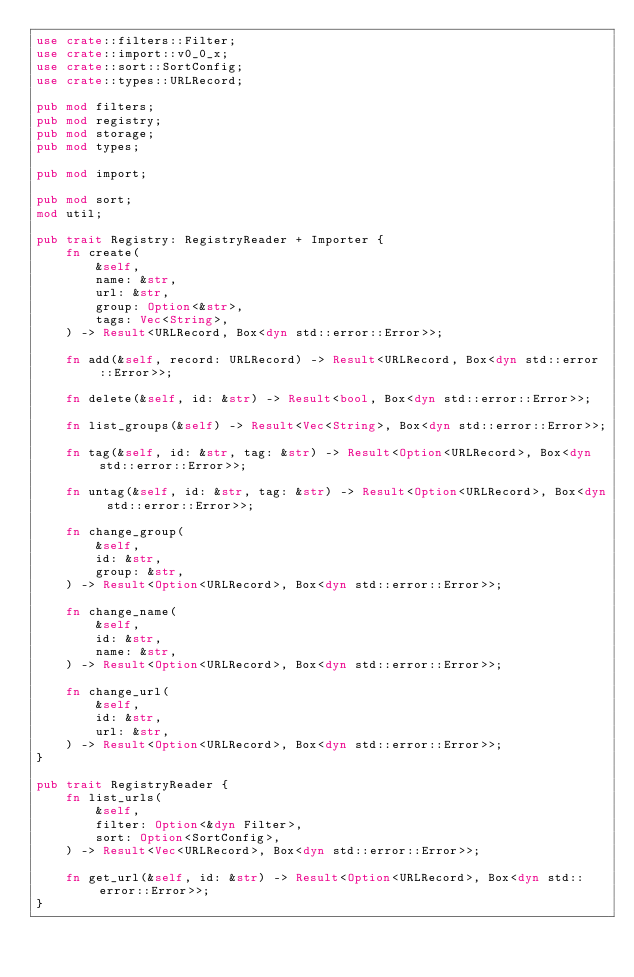<code> <loc_0><loc_0><loc_500><loc_500><_Rust_>use crate::filters::Filter;
use crate::import::v0_0_x;
use crate::sort::SortConfig;
use crate::types::URLRecord;

pub mod filters;
pub mod registry;
pub mod storage;
pub mod types;

pub mod import;

pub mod sort;
mod util;

pub trait Registry: RegistryReader + Importer {
    fn create(
        &self,
        name: &str,
        url: &str,
        group: Option<&str>,
        tags: Vec<String>,
    ) -> Result<URLRecord, Box<dyn std::error::Error>>;

    fn add(&self, record: URLRecord) -> Result<URLRecord, Box<dyn std::error::Error>>;

    fn delete(&self, id: &str) -> Result<bool, Box<dyn std::error::Error>>;

    fn list_groups(&self) -> Result<Vec<String>, Box<dyn std::error::Error>>;

    fn tag(&self, id: &str, tag: &str) -> Result<Option<URLRecord>, Box<dyn std::error::Error>>;

    fn untag(&self, id: &str, tag: &str) -> Result<Option<URLRecord>, Box<dyn std::error::Error>>;

    fn change_group(
        &self,
        id: &str,
        group: &str,
    ) -> Result<Option<URLRecord>, Box<dyn std::error::Error>>;

    fn change_name(
        &self,
        id: &str,
        name: &str,
    ) -> Result<Option<URLRecord>, Box<dyn std::error::Error>>;

    fn change_url(
        &self,
        id: &str,
        url: &str,
    ) -> Result<Option<URLRecord>, Box<dyn std::error::Error>>;
}

pub trait RegistryReader {
    fn list_urls(
        &self,
        filter: Option<&dyn Filter>,
        sort: Option<SortConfig>,
    ) -> Result<Vec<URLRecord>, Box<dyn std::error::Error>>;

    fn get_url(&self, id: &str) -> Result<Option<URLRecord>, Box<dyn std::error::Error>>;
}
</code> 